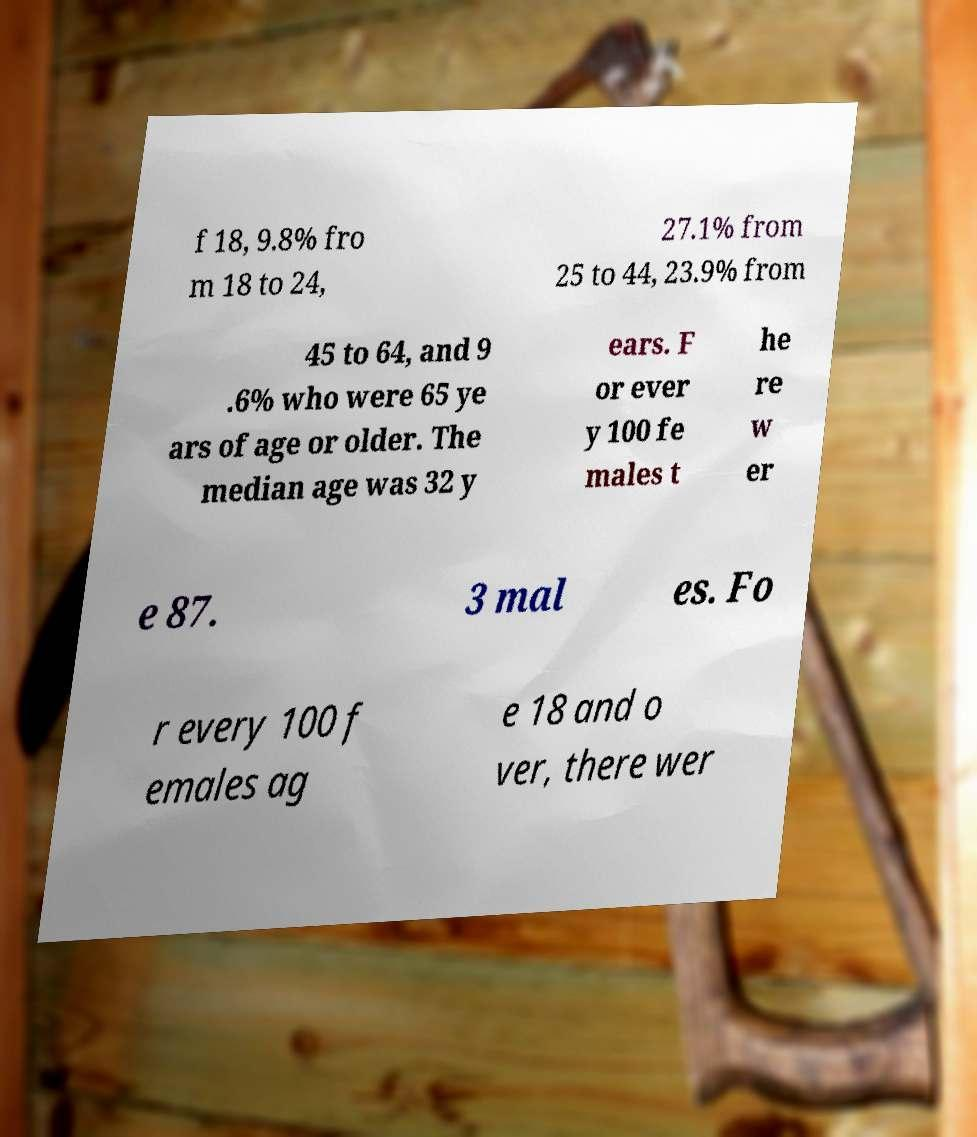Please read and relay the text visible in this image. What does it say? f 18, 9.8% fro m 18 to 24, 27.1% from 25 to 44, 23.9% from 45 to 64, and 9 .6% who were 65 ye ars of age or older. The median age was 32 y ears. F or ever y 100 fe males t he re w er e 87. 3 mal es. Fo r every 100 f emales ag e 18 and o ver, there wer 